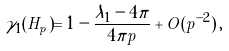<formula> <loc_0><loc_0><loc_500><loc_500>\gamma _ { 1 } ( H _ { p } ) = 1 - \frac { \lambda _ { 1 } - 4 \pi } { 4 \pi p } + O ( p ^ { - 2 } ) \, ,</formula> 